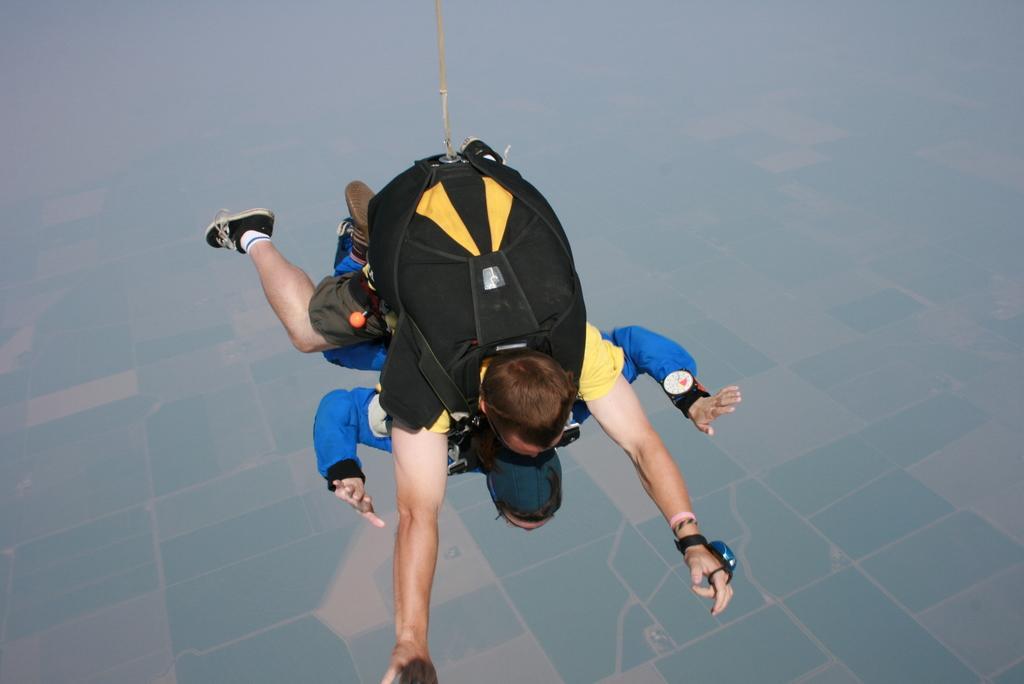Please provide a concise description of this image. In this picture we can observe two persons hanging to the rope. One of them is wearing blue color dress and other is wearing yellow color t-shirt. In the background we can observe floor. 